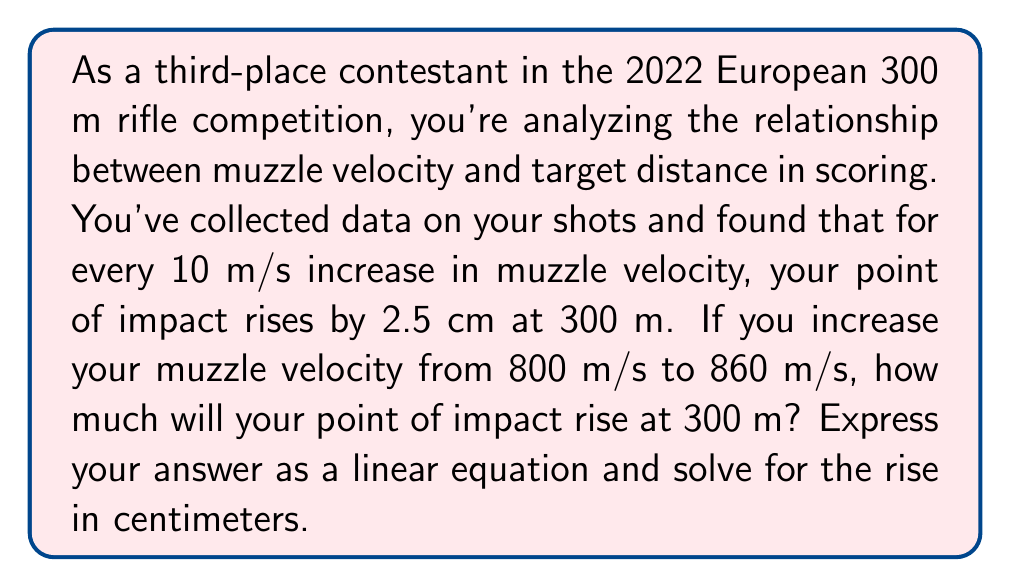Provide a solution to this math problem. Let's approach this step-by-step:

1) First, we need to establish our variables:
   Let $x$ be the increase in muzzle velocity in m/s
   Let $y$ be the rise in point of impact in cm

2) We're given that for every 10 m/s increase in velocity, the point of impact rises by 2.5 cm.
   This gives us our slope: $m = \frac{2.5 \text{ cm}}{10 \text{ m/s}} = 0.25 \text{ cm/(m/s)}$

3) We can now form our linear equation:
   $y = 0.25x$

4) The question asks about an increase from 800 m/s to 860 m/s.
   The change in velocity is: $860 - 800 = 60 \text{ m/s}$

5) Substituting this into our equation:
   $y = 0.25(60)$

6) Solving:
   $y = 15 \text{ cm}$

Therefore, the point of impact will rise by 15 cm at 300 m when the muzzle velocity is increased from 800 m/s to 860 m/s.
Answer: The linear equation is $y = 0.25x$, where $x$ is the increase in muzzle velocity in m/s and $y$ is the rise in point of impact in cm. For an increase of 60 m/s, the point of impact will rise by 15 cm. 